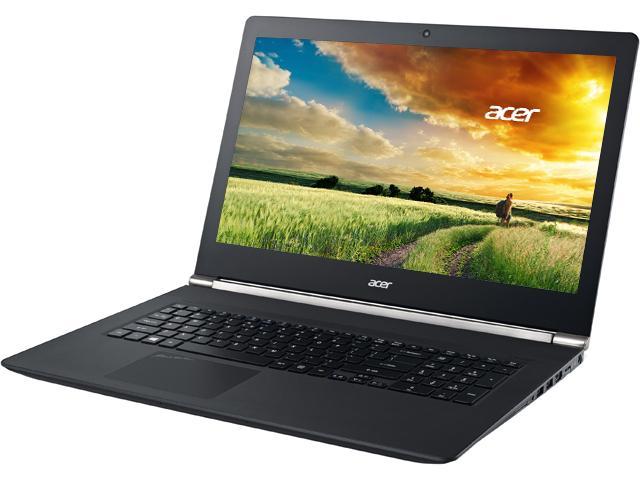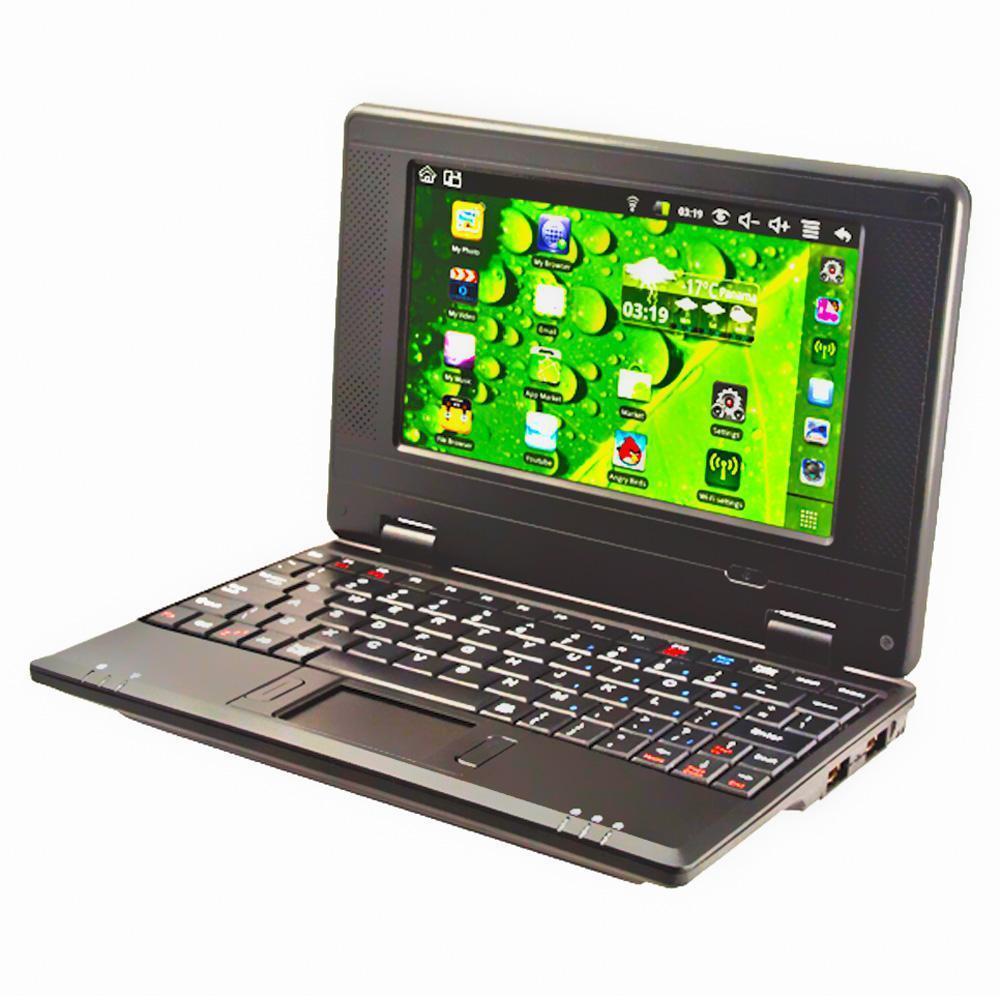The first image is the image on the left, the second image is the image on the right. Assess this claim about the two images: "Both computers are facing the left.". Correct or not? Answer yes or no. Yes. The first image is the image on the left, the second image is the image on the right. Given the left and right images, does the statement "Both images show an open laptop tilted so the screen aims leftward." hold true? Answer yes or no. Yes. 